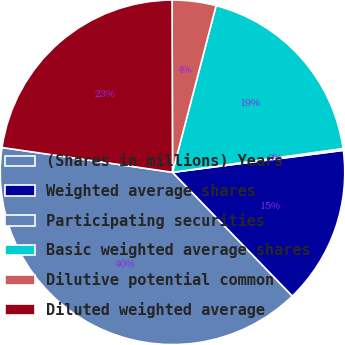Convert chart to OTSL. <chart><loc_0><loc_0><loc_500><loc_500><pie_chart><fcel>(Shares in millions) Years<fcel>Weighted average shares<fcel>Participating securities<fcel>Basic weighted average shares<fcel>Dilutive potential common<fcel>Diluted weighted average<nl><fcel>39.54%<fcel>14.79%<fcel>0.17%<fcel>18.72%<fcel>4.11%<fcel>22.66%<nl></chart> 